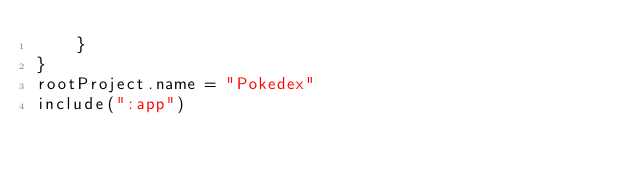<code> <loc_0><loc_0><loc_500><loc_500><_Kotlin_>    }
}
rootProject.name = "Pokedex"
include(":app")
</code> 